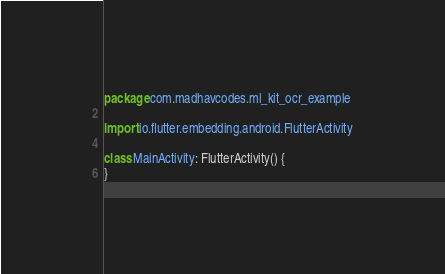<code> <loc_0><loc_0><loc_500><loc_500><_Kotlin_>package com.madhavcodes.ml_kit_ocr_example

import io.flutter.embedding.android.FlutterActivity

class MainActivity: FlutterActivity() {
}
</code> 